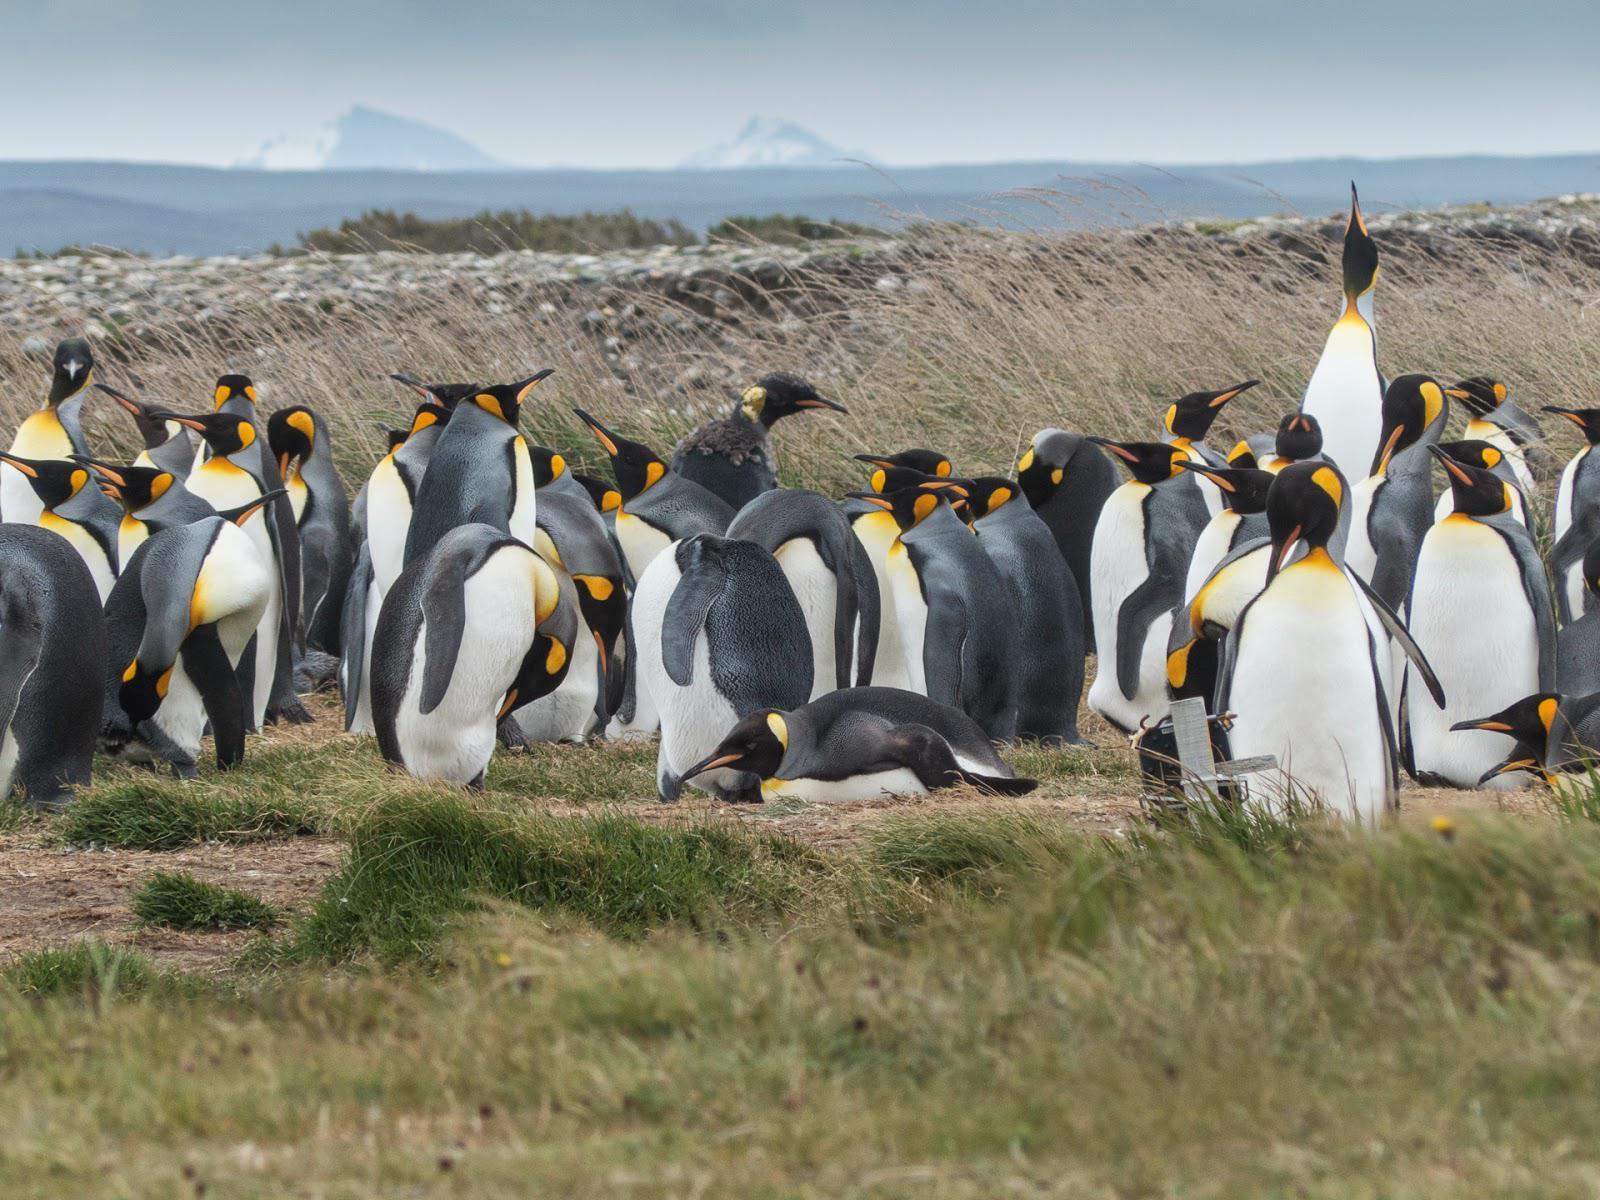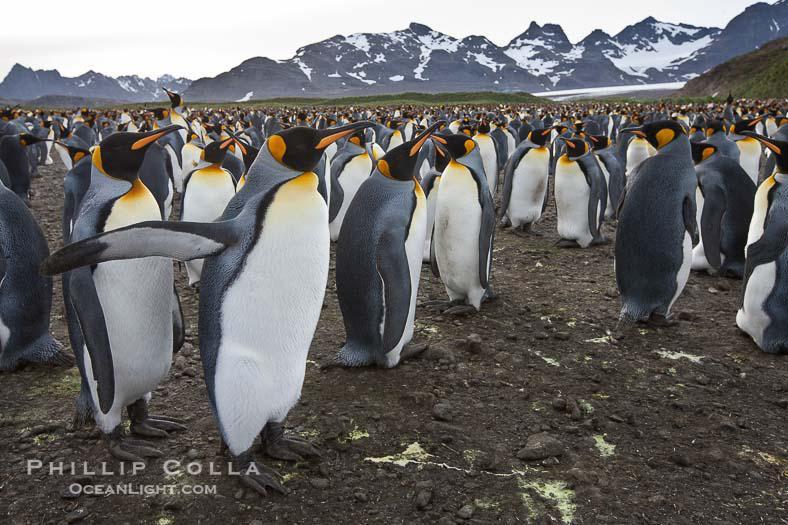The first image is the image on the left, the second image is the image on the right. Considering the images on both sides, is "A penguin is laying flat on the ground amid a big flock of penguins, in one image." valid? Answer yes or no. Yes. The first image is the image on the left, the second image is the image on the right. For the images shown, is this caption "At least one fuzzy brown chick is present." true? Answer yes or no. No. 